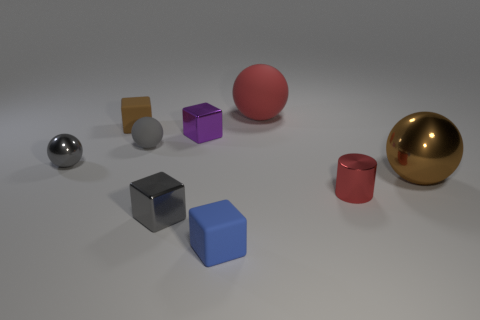How many objects are either gray shiny balls that are in front of the small gray matte sphere or small gray shiny things in front of the tiny red shiny thing?
Ensure brevity in your answer.  2. Are there more tiny blue things behind the brown rubber cube than tiny purple rubber cylinders?
Ensure brevity in your answer.  No. What number of blue metallic blocks have the same size as the purple shiny thing?
Ensure brevity in your answer.  0. There is a red thing behind the brown rubber thing; does it have the same size as the brown matte cube on the left side of the small red shiny thing?
Make the answer very short. No. There is a brown object in front of the small purple cube; what is its size?
Your answer should be compact. Large. There is a rubber sphere that is on the left side of the tiny shiny thing that is in front of the cylinder; what is its size?
Ensure brevity in your answer.  Small. What is the material of the brown thing that is the same size as the red rubber sphere?
Keep it short and to the point. Metal. Are there any blue cubes on the left side of the tiny blue block?
Make the answer very short. No. Are there an equal number of gray shiny objects behind the large red sphere and brown spheres?
Offer a terse response. No. What shape is the red metal object that is the same size as the purple thing?
Your response must be concise. Cylinder. 